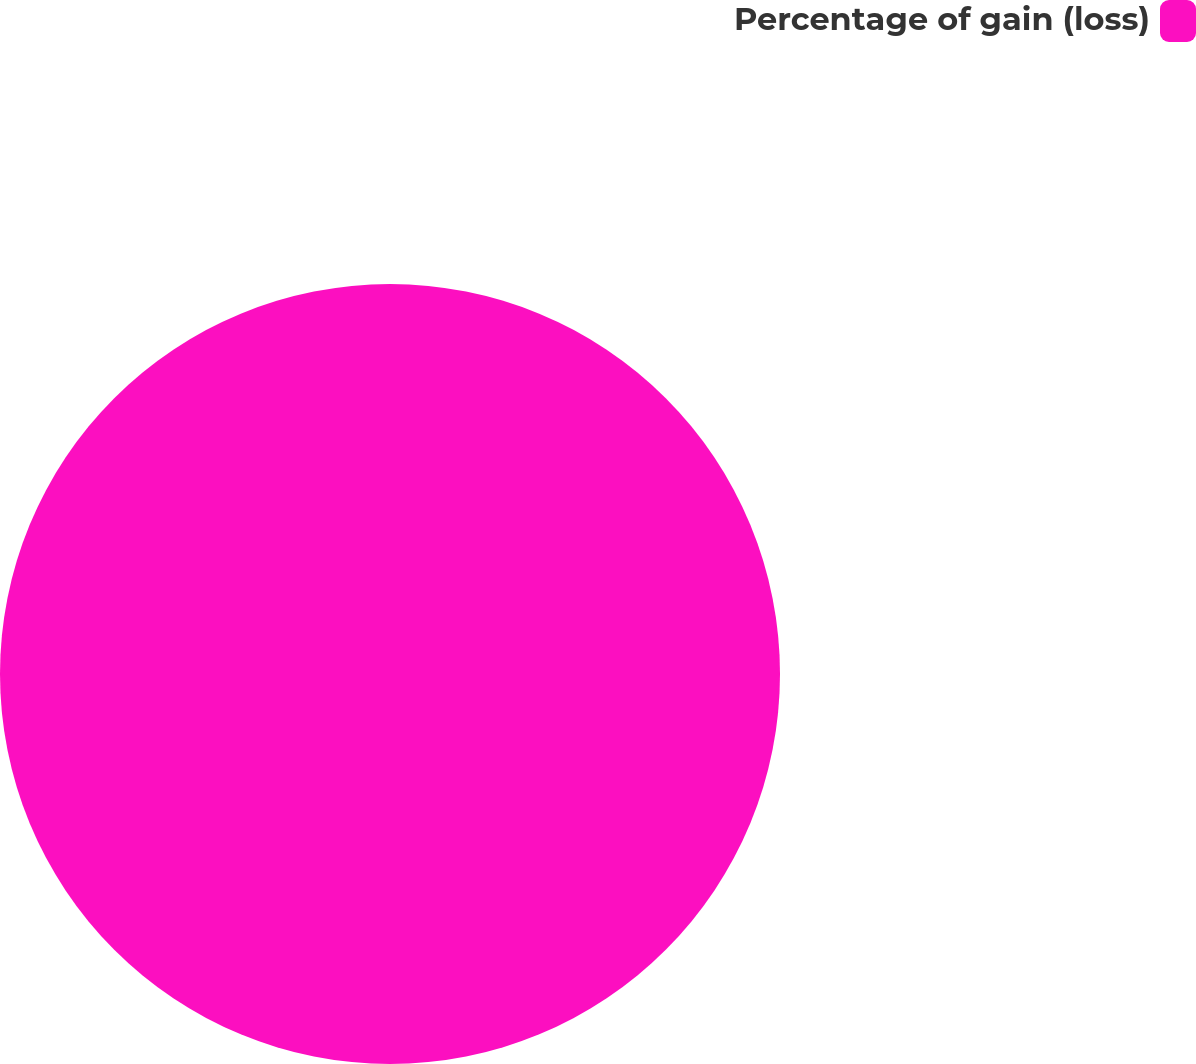Convert chart to OTSL. <chart><loc_0><loc_0><loc_500><loc_500><pie_chart><fcel>Percentage of gain (loss)<nl><fcel>100.0%<nl></chart> 